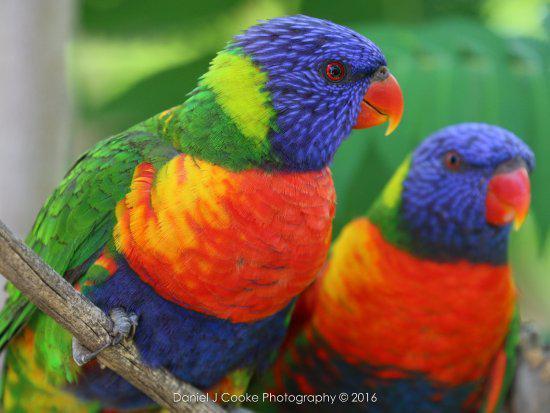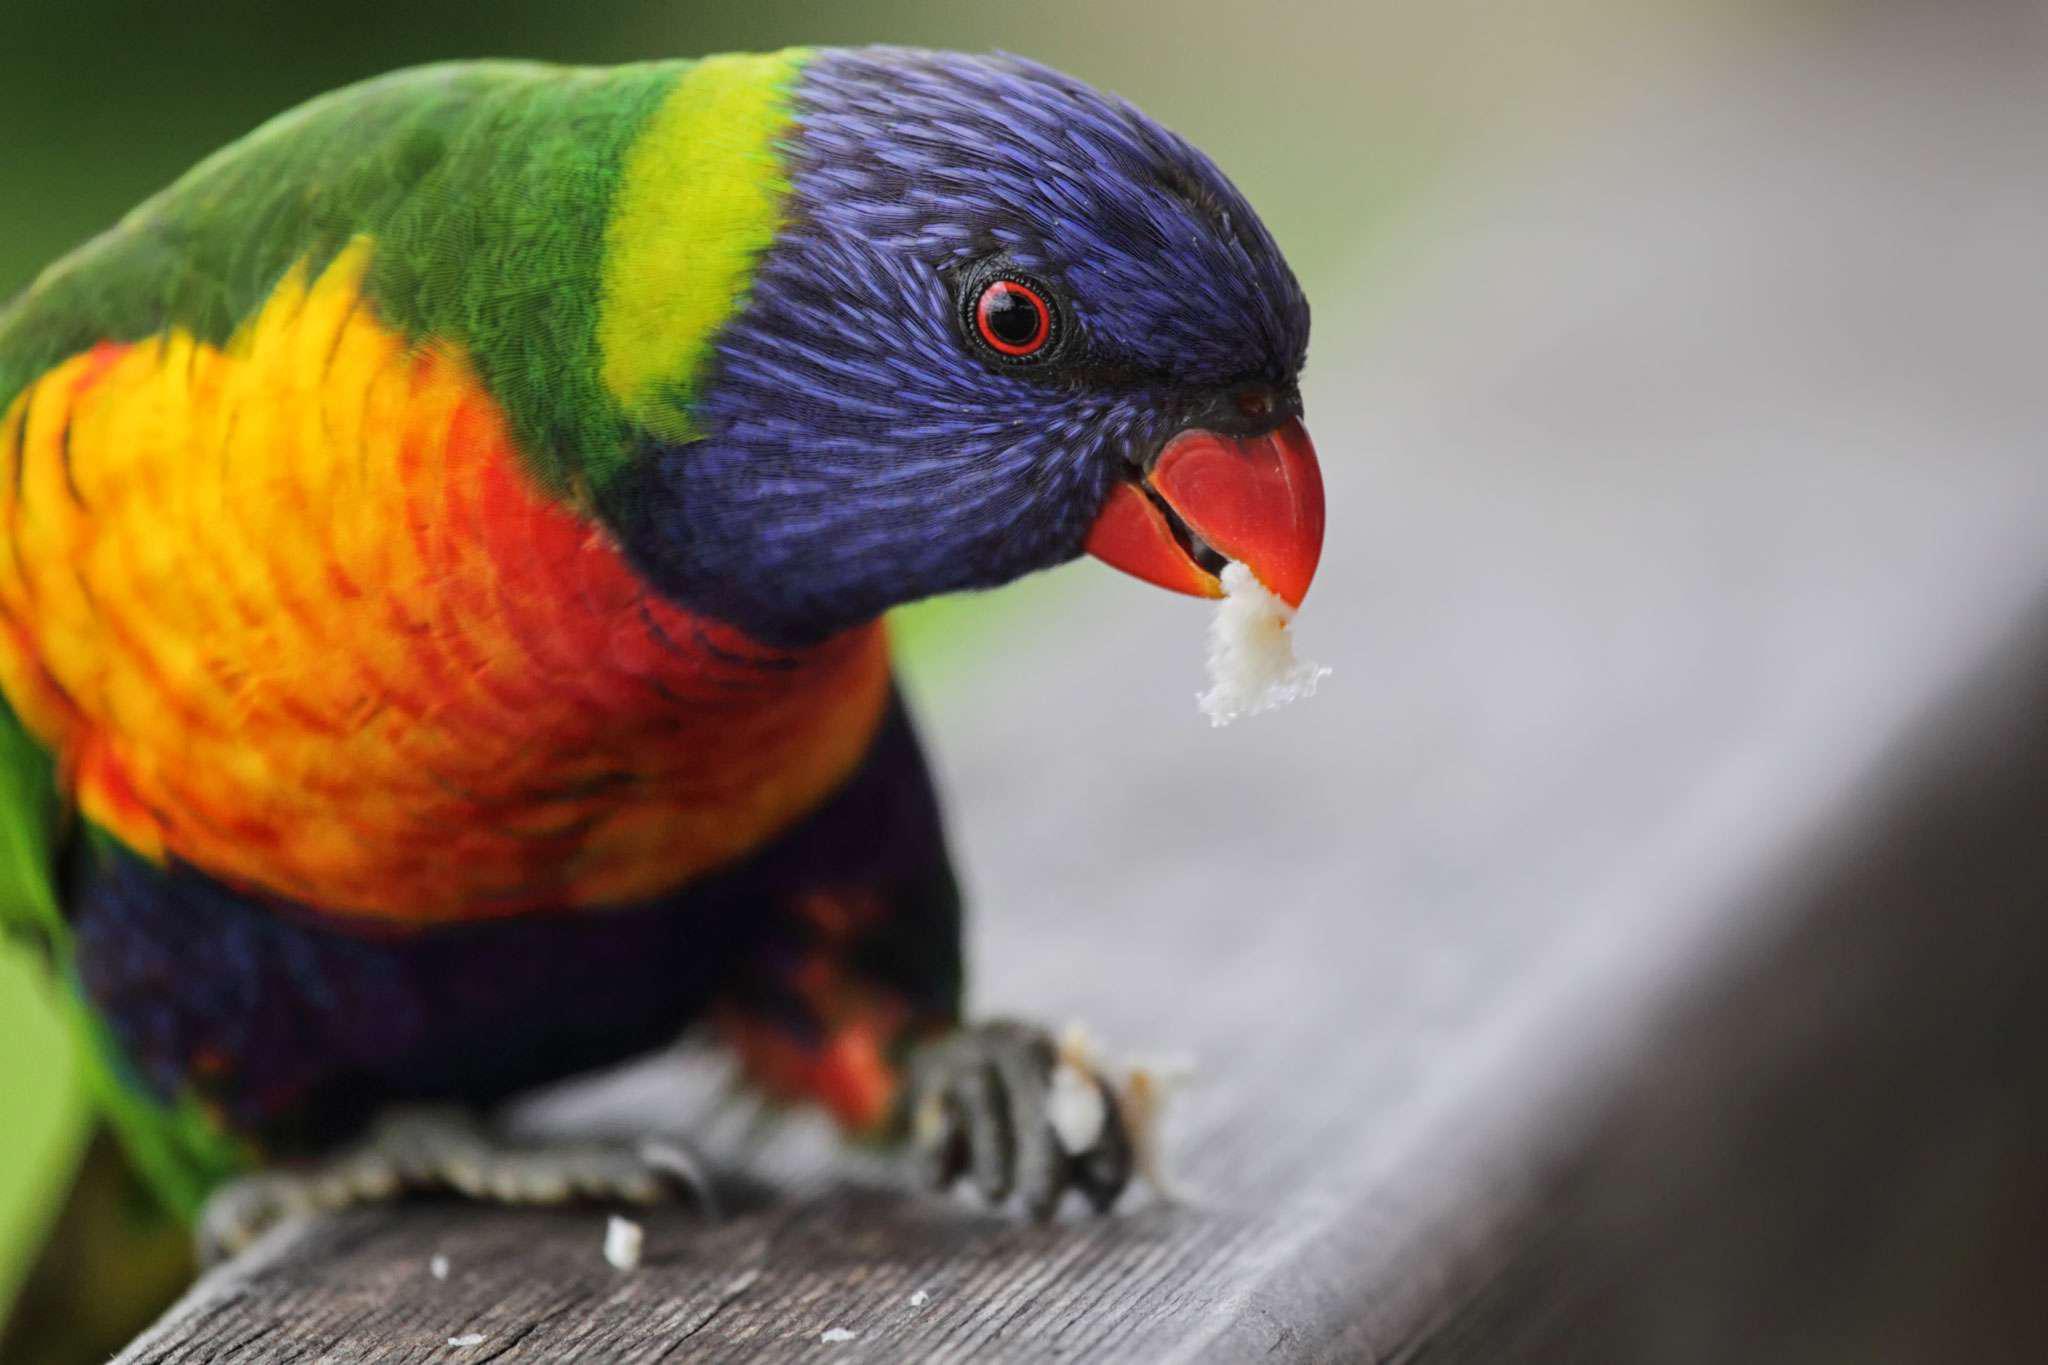The first image is the image on the left, the second image is the image on the right. Assess this claim about the two images: "There are three birds". Correct or not? Answer yes or no. Yes. 